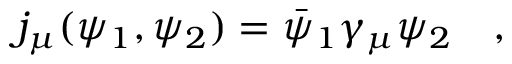<formula> <loc_0><loc_0><loc_500><loc_500>j _ { \mu } ( \psi _ { 1 } , \psi _ { 2 } ) = \bar { \psi } _ { 1 } \gamma _ { \mu } \psi _ { 2 } ,</formula> 